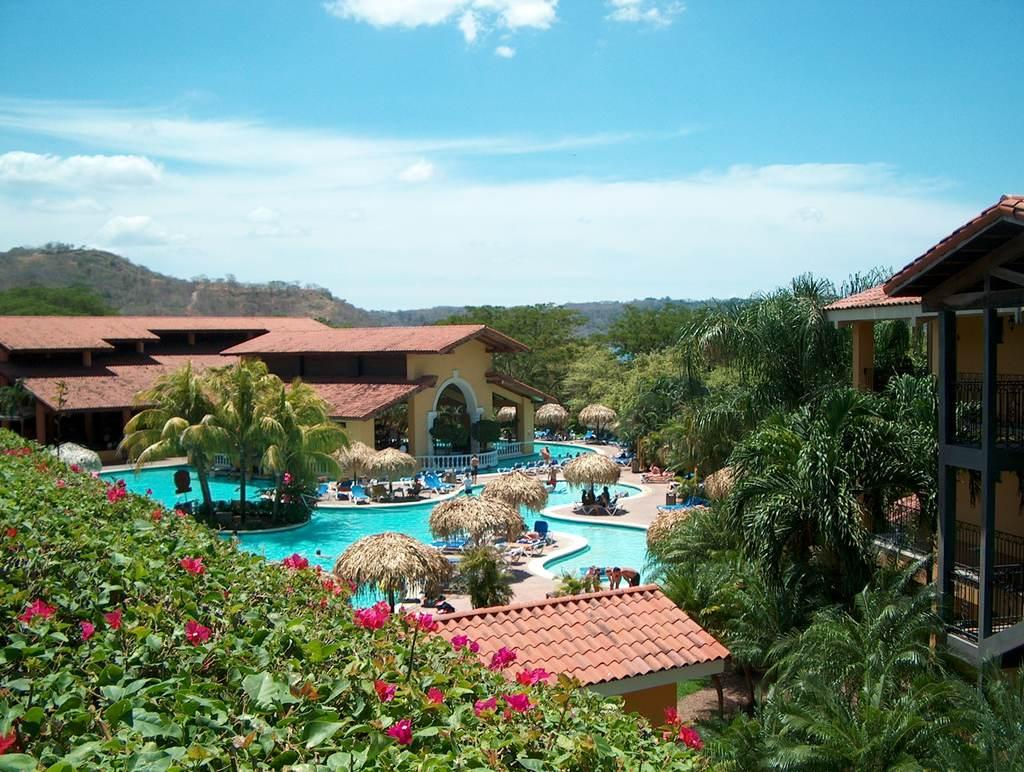What type of natural elements can be seen in the image? There are trees, plants, flowers, and a hill visible in the image. What type of structures are present in the image? There are houses, shacks, and a swimming pool in the image. What type of outdoor furniture can be seen in the image? There are chairs in the image. What is visible in the sky in the image? There is sky visible in the image, with clouds present. What type of utensil is being used to draw on the shacks in the image? There is no utensil or drawing activity present in the image; the shacks are simply structures. What color is the ink used to paint the flowers in the image? There is no ink or painting activity present in the image; the flowers are naturally colored. 